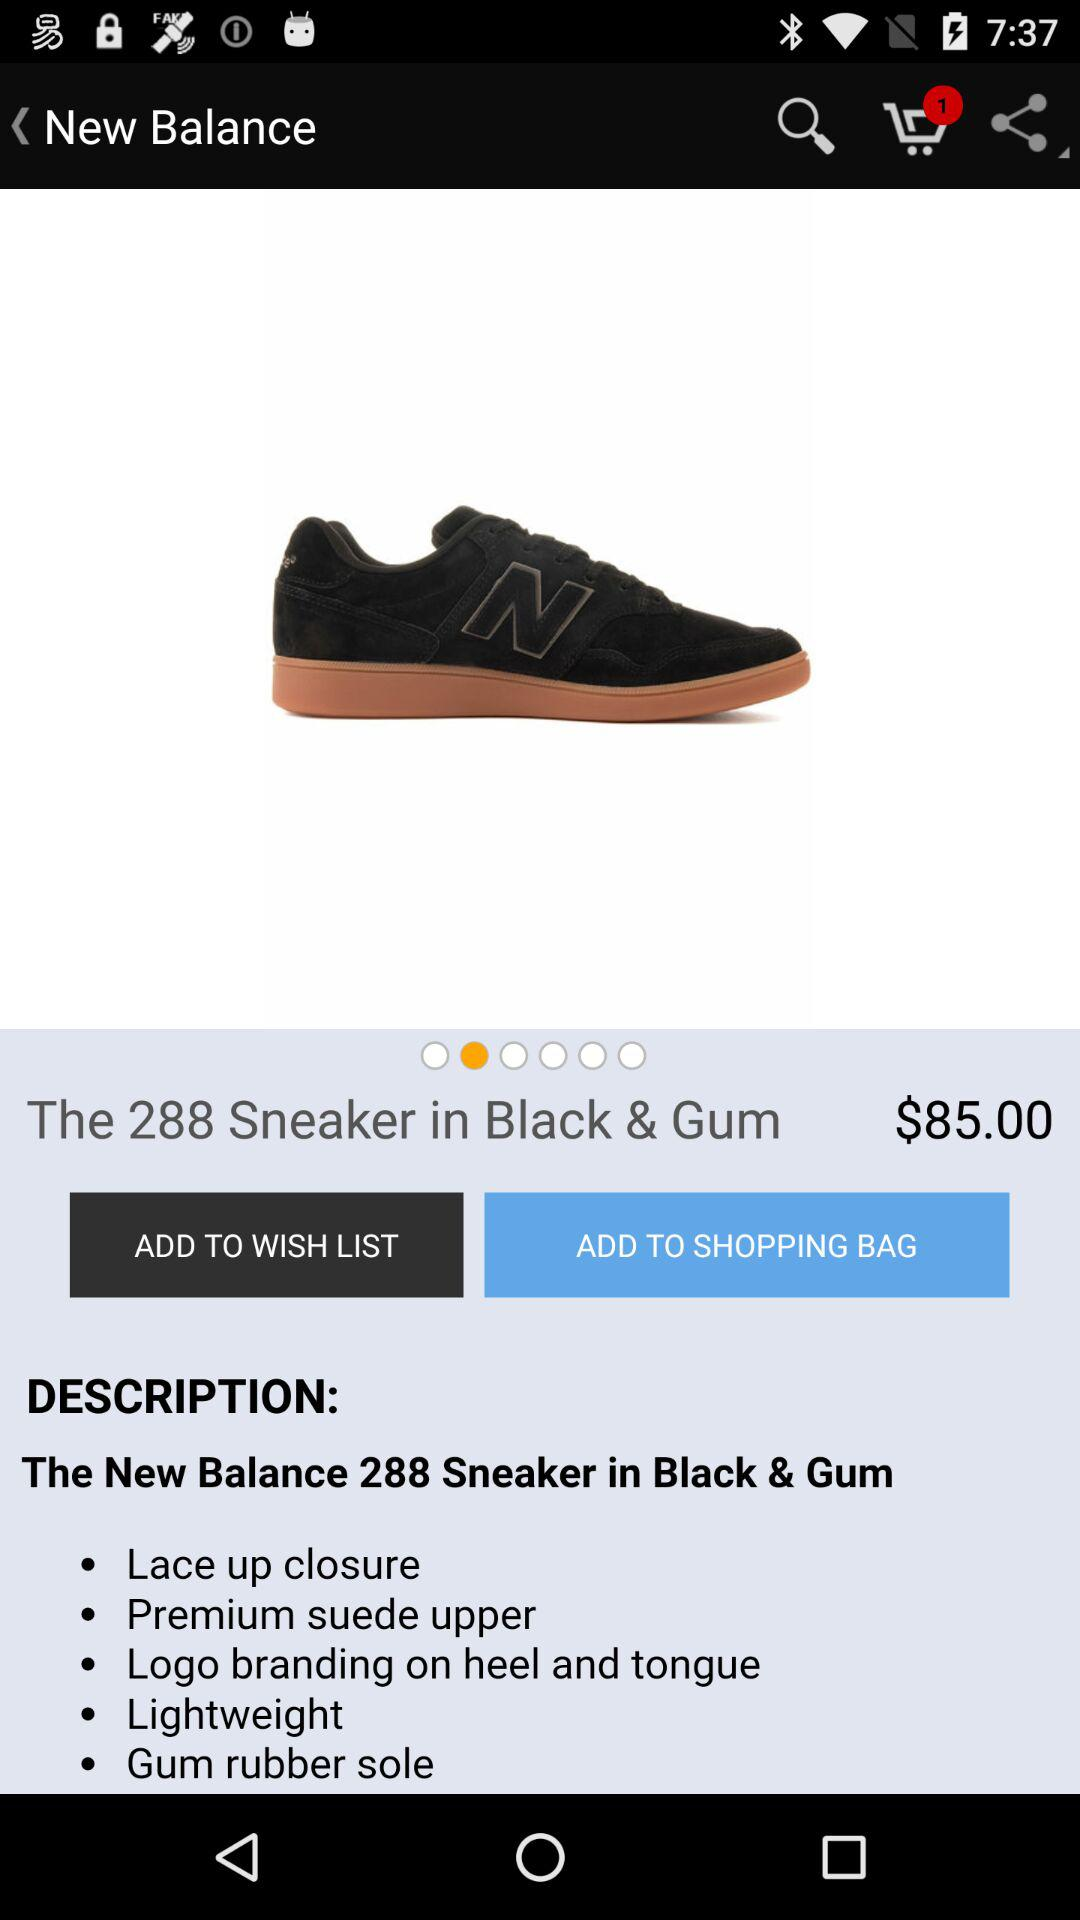What is the new balance of sneaker?
When the provided information is insufficient, respond with <no answer>. <no answer> 